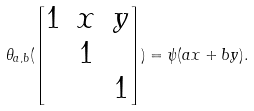Convert formula to latex. <formula><loc_0><loc_0><loc_500><loc_500>\theta _ { a , b } ( \begin{bmatrix} 1 & x & y \\ & 1 \\ & & 1 \end{bmatrix} ) = \psi ( a x + b y ) .</formula> 